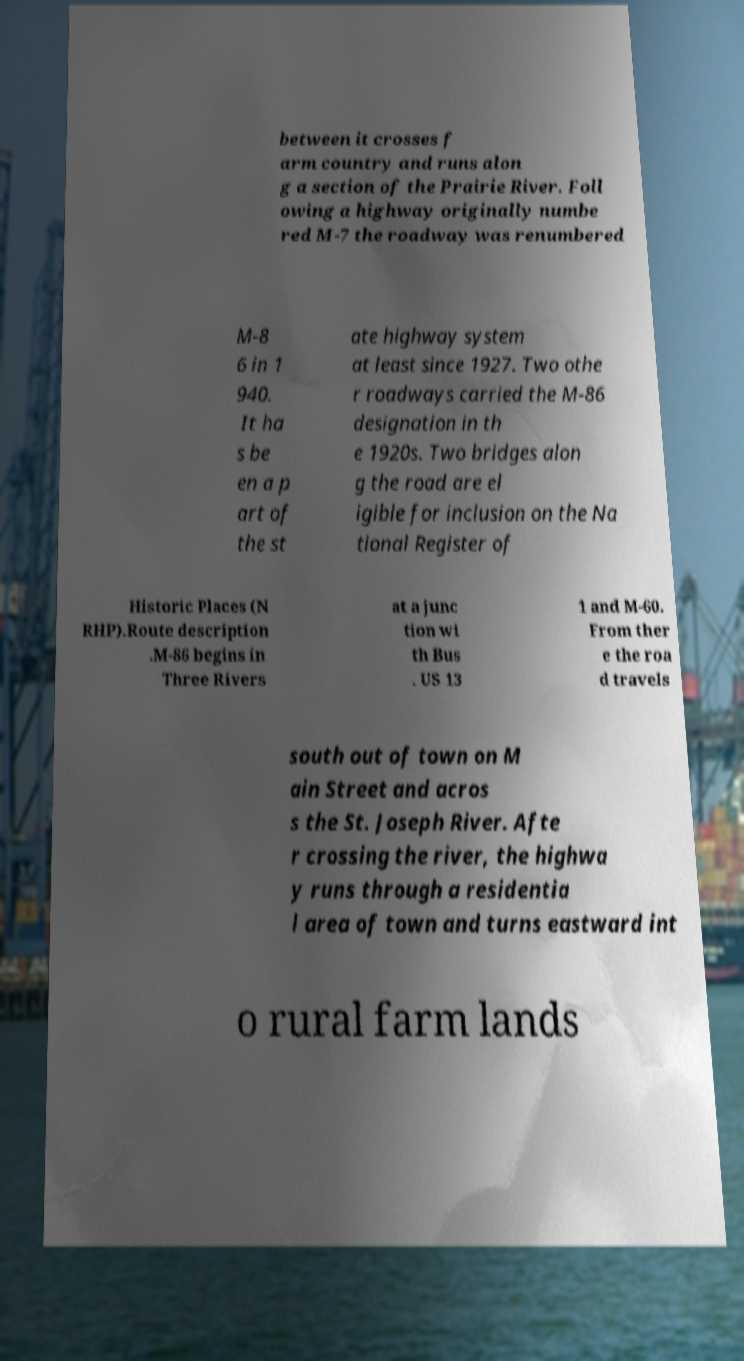Can you accurately transcribe the text from the provided image for me? between it crosses f arm country and runs alon g a section of the Prairie River. Foll owing a highway originally numbe red M-7 the roadway was renumbered M-8 6 in 1 940. It ha s be en a p art of the st ate highway system at least since 1927. Two othe r roadways carried the M-86 designation in th e 1920s. Two bridges alon g the road are el igible for inclusion on the Na tional Register of Historic Places (N RHP).Route description .M-86 begins in Three Rivers at a junc tion wi th Bus . US 13 1 and M-60. From ther e the roa d travels south out of town on M ain Street and acros s the St. Joseph River. Afte r crossing the river, the highwa y runs through a residentia l area of town and turns eastward int o rural farm lands 